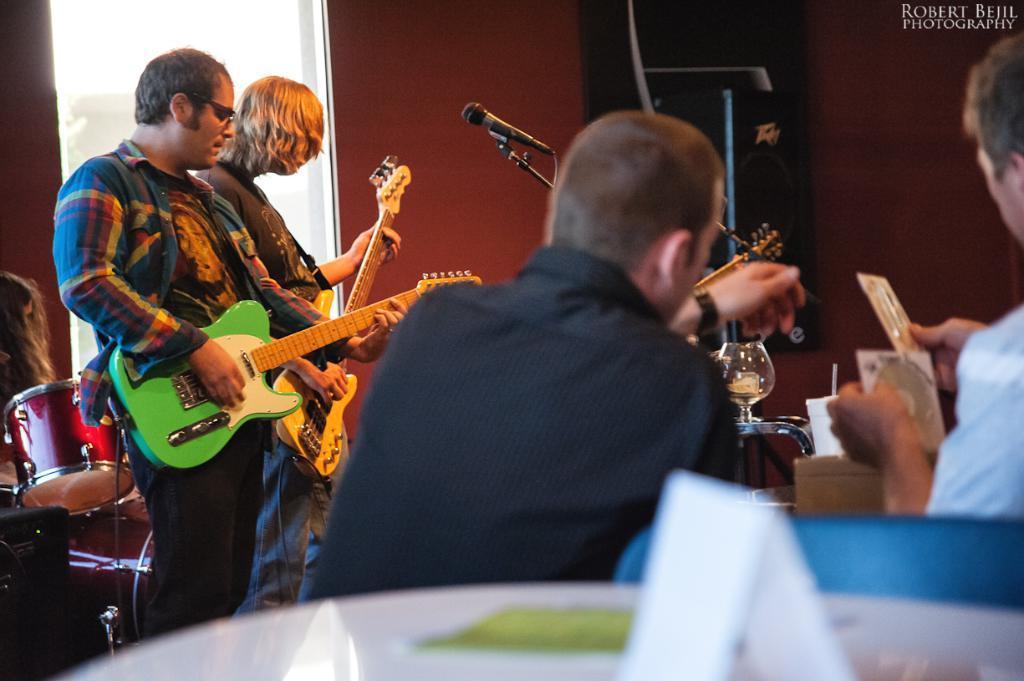Can you describe this image briefly? This two persons are playing guitars in-front of mics. Corner of the room there is a speaker. The wall is in red color. Backside of this person's there is a musical drum This two persons are sitting on chairs. This man wore black shirt and this man is holding a CD. On this table there is a card. 